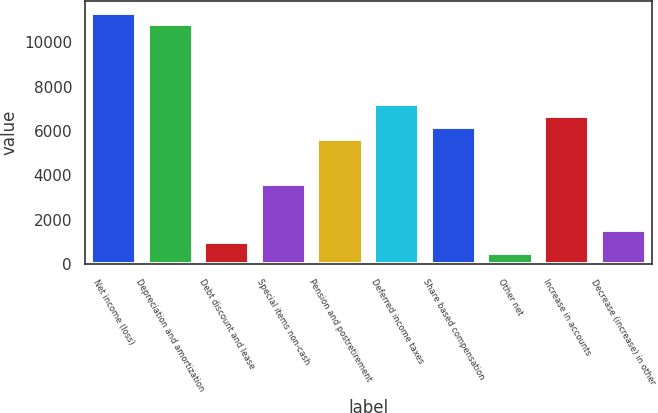<chart> <loc_0><loc_0><loc_500><loc_500><bar_chart><fcel>Net income (loss)<fcel>Depreciation and amortization<fcel>Debt discount and lease<fcel>Special items non-cash<fcel>Pension and postretirement<fcel>Deferred income taxes<fcel>Share based compensation<fcel>Other net<fcel>Increase in accounts<fcel>Decrease (increase) in other<nl><fcel>11303.4<fcel>10789.7<fcel>1029.4<fcel>3597.9<fcel>5652.7<fcel>7193.8<fcel>6166.4<fcel>515.7<fcel>6680.1<fcel>1543.1<nl></chart> 